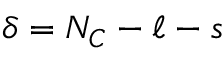Convert formula to latex. <formula><loc_0><loc_0><loc_500><loc_500>\delta = N _ { C } - \ell - s</formula> 